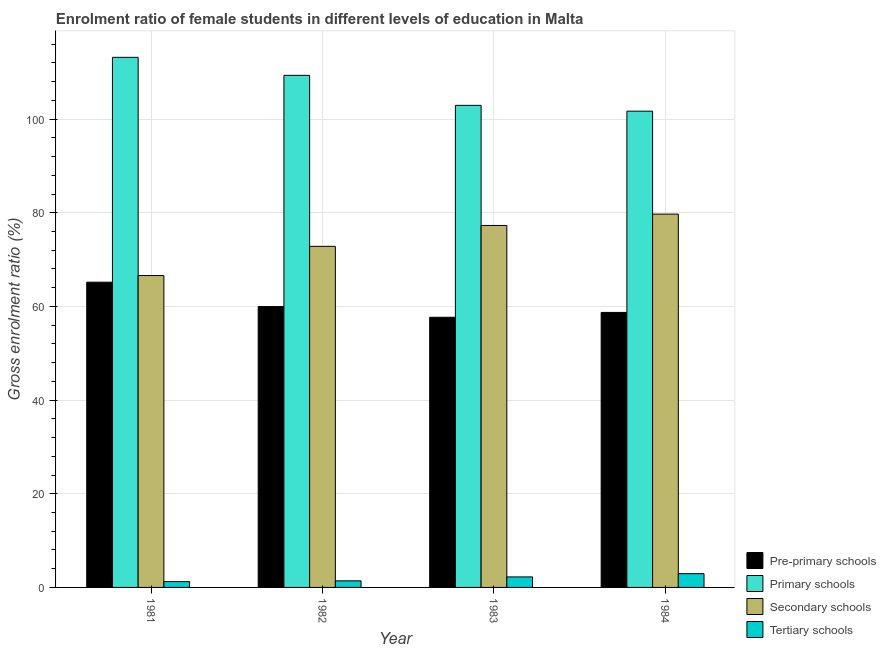How many different coloured bars are there?
Your answer should be very brief. 4. How many groups of bars are there?
Ensure brevity in your answer.  4. How many bars are there on the 1st tick from the left?
Offer a very short reply. 4. What is the label of the 4th group of bars from the left?
Ensure brevity in your answer.  1984. In how many cases, is the number of bars for a given year not equal to the number of legend labels?
Offer a terse response. 0. What is the gross enrolment ratio(male) in secondary schools in 1982?
Provide a short and direct response. 72.84. Across all years, what is the maximum gross enrolment ratio(male) in secondary schools?
Your answer should be compact. 79.72. Across all years, what is the minimum gross enrolment ratio(male) in secondary schools?
Give a very brief answer. 66.6. In which year was the gross enrolment ratio(male) in pre-primary schools minimum?
Ensure brevity in your answer.  1983. What is the total gross enrolment ratio(male) in primary schools in the graph?
Your answer should be compact. 427.19. What is the difference between the gross enrolment ratio(male) in pre-primary schools in 1981 and that in 1982?
Offer a terse response. 5.21. What is the difference between the gross enrolment ratio(male) in primary schools in 1981 and the gross enrolment ratio(male) in secondary schools in 1984?
Your response must be concise. 11.5. What is the average gross enrolment ratio(male) in tertiary schools per year?
Provide a succinct answer. 1.96. What is the ratio of the gross enrolment ratio(male) in pre-primary schools in 1982 to that in 1983?
Offer a terse response. 1.04. Is the difference between the gross enrolment ratio(male) in primary schools in 1983 and 1984 greater than the difference between the gross enrolment ratio(male) in secondary schools in 1983 and 1984?
Give a very brief answer. No. What is the difference between the highest and the second highest gross enrolment ratio(male) in secondary schools?
Give a very brief answer. 2.42. What is the difference between the highest and the lowest gross enrolment ratio(male) in pre-primary schools?
Provide a short and direct response. 7.49. In how many years, is the gross enrolment ratio(male) in tertiary schools greater than the average gross enrolment ratio(male) in tertiary schools taken over all years?
Keep it short and to the point. 2. Is the sum of the gross enrolment ratio(male) in tertiary schools in 1981 and 1984 greater than the maximum gross enrolment ratio(male) in primary schools across all years?
Give a very brief answer. Yes. What does the 4th bar from the left in 1981 represents?
Offer a very short reply. Tertiary schools. What does the 4th bar from the right in 1983 represents?
Give a very brief answer. Pre-primary schools. Is it the case that in every year, the sum of the gross enrolment ratio(male) in pre-primary schools and gross enrolment ratio(male) in primary schools is greater than the gross enrolment ratio(male) in secondary schools?
Offer a terse response. Yes. How many bars are there?
Offer a terse response. 16. What is the difference between two consecutive major ticks on the Y-axis?
Make the answer very short. 20. Does the graph contain grids?
Keep it short and to the point. Yes. How are the legend labels stacked?
Keep it short and to the point. Vertical. What is the title of the graph?
Your response must be concise. Enrolment ratio of female students in different levels of education in Malta. What is the label or title of the X-axis?
Ensure brevity in your answer.  Year. What is the label or title of the Y-axis?
Your response must be concise. Gross enrolment ratio (%). What is the Gross enrolment ratio (%) in Pre-primary schools in 1981?
Offer a terse response. 65.18. What is the Gross enrolment ratio (%) of Primary schools in 1981?
Offer a terse response. 113.2. What is the Gross enrolment ratio (%) of Secondary schools in 1981?
Provide a succinct answer. 66.6. What is the Gross enrolment ratio (%) in Tertiary schools in 1981?
Make the answer very short. 1.24. What is the Gross enrolment ratio (%) of Pre-primary schools in 1982?
Offer a terse response. 59.98. What is the Gross enrolment ratio (%) in Primary schools in 1982?
Provide a succinct answer. 109.35. What is the Gross enrolment ratio (%) in Secondary schools in 1982?
Make the answer very short. 72.84. What is the Gross enrolment ratio (%) of Tertiary schools in 1982?
Keep it short and to the point. 1.4. What is the Gross enrolment ratio (%) in Pre-primary schools in 1983?
Your answer should be compact. 57.69. What is the Gross enrolment ratio (%) in Primary schools in 1983?
Provide a short and direct response. 102.94. What is the Gross enrolment ratio (%) of Secondary schools in 1983?
Offer a very short reply. 77.29. What is the Gross enrolment ratio (%) in Tertiary schools in 1983?
Your answer should be compact. 2.24. What is the Gross enrolment ratio (%) of Pre-primary schools in 1984?
Your answer should be very brief. 58.73. What is the Gross enrolment ratio (%) of Primary schools in 1984?
Ensure brevity in your answer.  101.7. What is the Gross enrolment ratio (%) of Secondary schools in 1984?
Your answer should be compact. 79.72. What is the Gross enrolment ratio (%) in Tertiary schools in 1984?
Offer a very short reply. 2.94. Across all years, what is the maximum Gross enrolment ratio (%) of Pre-primary schools?
Your answer should be compact. 65.18. Across all years, what is the maximum Gross enrolment ratio (%) of Primary schools?
Offer a very short reply. 113.2. Across all years, what is the maximum Gross enrolment ratio (%) of Secondary schools?
Ensure brevity in your answer.  79.72. Across all years, what is the maximum Gross enrolment ratio (%) in Tertiary schools?
Provide a succinct answer. 2.94. Across all years, what is the minimum Gross enrolment ratio (%) in Pre-primary schools?
Offer a very short reply. 57.69. Across all years, what is the minimum Gross enrolment ratio (%) in Primary schools?
Offer a terse response. 101.7. Across all years, what is the minimum Gross enrolment ratio (%) of Secondary schools?
Offer a terse response. 66.6. Across all years, what is the minimum Gross enrolment ratio (%) of Tertiary schools?
Your answer should be compact. 1.24. What is the total Gross enrolment ratio (%) of Pre-primary schools in the graph?
Provide a succinct answer. 241.57. What is the total Gross enrolment ratio (%) of Primary schools in the graph?
Offer a terse response. 427.19. What is the total Gross enrolment ratio (%) of Secondary schools in the graph?
Give a very brief answer. 296.45. What is the total Gross enrolment ratio (%) of Tertiary schools in the graph?
Your answer should be compact. 7.83. What is the difference between the Gross enrolment ratio (%) in Pre-primary schools in 1981 and that in 1982?
Your response must be concise. 5.21. What is the difference between the Gross enrolment ratio (%) of Primary schools in 1981 and that in 1982?
Make the answer very short. 3.85. What is the difference between the Gross enrolment ratio (%) of Secondary schools in 1981 and that in 1982?
Give a very brief answer. -6.24. What is the difference between the Gross enrolment ratio (%) in Tertiary schools in 1981 and that in 1982?
Make the answer very short. -0.16. What is the difference between the Gross enrolment ratio (%) in Pre-primary schools in 1981 and that in 1983?
Ensure brevity in your answer.  7.49. What is the difference between the Gross enrolment ratio (%) in Primary schools in 1981 and that in 1983?
Your answer should be compact. 10.26. What is the difference between the Gross enrolment ratio (%) of Secondary schools in 1981 and that in 1983?
Your answer should be compact. -10.69. What is the difference between the Gross enrolment ratio (%) in Tertiary schools in 1981 and that in 1983?
Provide a succinct answer. -1. What is the difference between the Gross enrolment ratio (%) in Pre-primary schools in 1981 and that in 1984?
Your answer should be compact. 6.46. What is the difference between the Gross enrolment ratio (%) in Primary schools in 1981 and that in 1984?
Provide a short and direct response. 11.5. What is the difference between the Gross enrolment ratio (%) in Secondary schools in 1981 and that in 1984?
Ensure brevity in your answer.  -13.12. What is the difference between the Gross enrolment ratio (%) in Tertiary schools in 1981 and that in 1984?
Your answer should be compact. -1.7. What is the difference between the Gross enrolment ratio (%) of Pre-primary schools in 1982 and that in 1983?
Your response must be concise. 2.29. What is the difference between the Gross enrolment ratio (%) of Primary schools in 1982 and that in 1983?
Your response must be concise. 6.41. What is the difference between the Gross enrolment ratio (%) of Secondary schools in 1982 and that in 1983?
Offer a terse response. -4.46. What is the difference between the Gross enrolment ratio (%) of Tertiary schools in 1982 and that in 1983?
Make the answer very short. -0.84. What is the difference between the Gross enrolment ratio (%) in Pre-primary schools in 1982 and that in 1984?
Offer a terse response. 1.25. What is the difference between the Gross enrolment ratio (%) in Primary schools in 1982 and that in 1984?
Provide a succinct answer. 7.65. What is the difference between the Gross enrolment ratio (%) of Secondary schools in 1982 and that in 1984?
Keep it short and to the point. -6.88. What is the difference between the Gross enrolment ratio (%) of Tertiary schools in 1982 and that in 1984?
Your answer should be compact. -1.54. What is the difference between the Gross enrolment ratio (%) in Pre-primary schools in 1983 and that in 1984?
Give a very brief answer. -1.04. What is the difference between the Gross enrolment ratio (%) in Primary schools in 1983 and that in 1984?
Ensure brevity in your answer.  1.24. What is the difference between the Gross enrolment ratio (%) in Secondary schools in 1983 and that in 1984?
Offer a terse response. -2.42. What is the difference between the Gross enrolment ratio (%) in Tertiary schools in 1983 and that in 1984?
Offer a very short reply. -0.7. What is the difference between the Gross enrolment ratio (%) of Pre-primary schools in 1981 and the Gross enrolment ratio (%) of Primary schools in 1982?
Keep it short and to the point. -44.17. What is the difference between the Gross enrolment ratio (%) in Pre-primary schools in 1981 and the Gross enrolment ratio (%) in Secondary schools in 1982?
Ensure brevity in your answer.  -7.65. What is the difference between the Gross enrolment ratio (%) in Pre-primary schools in 1981 and the Gross enrolment ratio (%) in Tertiary schools in 1982?
Offer a terse response. 63.78. What is the difference between the Gross enrolment ratio (%) of Primary schools in 1981 and the Gross enrolment ratio (%) of Secondary schools in 1982?
Give a very brief answer. 40.36. What is the difference between the Gross enrolment ratio (%) of Primary schools in 1981 and the Gross enrolment ratio (%) of Tertiary schools in 1982?
Give a very brief answer. 111.8. What is the difference between the Gross enrolment ratio (%) of Secondary schools in 1981 and the Gross enrolment ratio (%) of Tertiary schools in 1982?
Keep it short and to the point. 65.2. What is the difference between the Gross enrolment ratio (%) of Pre-primary schools in 1981 and the Gross enrolment ratio (%) of Primary schools in 1983?
Offer a terse response. -37.76. What is the difference between the Gross enrolment ratio (%) in Pre-primary schools in 1981 and the Gross enrolment ratio (%) in Secondary schools in 1983?
Keep it short and to the point. -12.11. What is the difference between the Gross enrolment ratio (%) in Pre-primary schools in 1981 and the Gross enrolment ratio (%) in Tertiary schools in 1983?
Provide a succinct answer. 62.94. What is the difference between the Gross enrolment ratio (%) in Primary schools in 1981 and the Gross enrolment ratio (%) in Secondary schools in 1983?
Make the answer very short. 35.9. What is the difference between the Gross enrolment ratio (%) of Primary schools in 1981 and the Gross enrolment ratio (%) of Tertiary schools in 1983?
Offer a very short reply. 110.95. What is the difference between the Gross enrolment ratio (%) in Secondary schools in 1981 and the Gross enrolment ratio (%) in Tertiary schools in 1983?
Provide a succinct answer. 64.36. What is the difference between the Gross enrolment ratio (%) in Pre-primary schools in 1981 and the Gross enrolment ratio (%) in Primary schools in 1984?
Your answer should be very brief. -36.52. What is the difference between the Gross enrolment ratio (%) of Pre-primary schools in 1981 and the Gross enrolment ratio (%) of Secondary schools in 1984?
Your answer should be very brief. -14.54. What is the difference between the Gross enrolment ratio (%) in Pre-primary schools in 1981 and the Gross enrolment ratio (%) in Tertiary schools in 1984?
Offer a very short reply. 62.24. What is the difference between the Gross enrolment ratio (%) in Primary schools in 1981 and the Gross enrolment ratio (%) in Secondary schools in 1984?
Your answer should be very brief. 33.48. What is the difference between the Gross enrolment ratio (%) in Primary schools in 1981 and the Gross enrolment ratio (%) in Tertiary schools in 1984?
Your answer should be very brief. 110.25. What is the difference between the Gross enrolment ratio (%) in Secondary schools in 1981 and the Gross enrolment ratio (%) in Tertiary schools in 1984?
Give a very brief answer. 63.66. What is the difference between the Gross enrolment ratio (%) of Pre-primary schools in 1982 and the Gross enrolment ratio (%) of Primary schools in 1983?
Offer a very short reply. -42.96. What is the difference between the Gross enrolment ratio (%) in Pre-primary schools in 1982 and the Gross enrolment ratio (%) in Secondary schools in 1983?
Keep it short and to the point. -17.32. What is the difference between the Gross enrolment ratio (%) in Pre-primary schools in 1982 and the Gross enrolment ratio (%) in Tertiary schools in 1983?
Give a very brief answer. 57.73. What is the difference between the Gross enrolment ratio (%) of Primary schools in 1982 and the Gross enrolment ratio (%) of Secondary schools in 1983?
Give a very brief answer. 32.06. What is the difference between the Gross enrolment ratio (%) of Primary schools in 1982 and the Gross enrolment ratio (%) of Tertiary schools in 1983?
Make the answer very short. 107.11. What is the difference between the Gross enrolment ratio (%) of Secondary schools in 1982 and the Gross enrolment ratio (%) of Tertiary schools in 1983?
Offer a terse response. 70.59. What is the difference between the Gross enrolment ratio (%) in Pre-primary schools in 1982 and the Gross enrolment ratio (%) in Primary schools in 1984?
Ensure brevity in your answer.  -41.73. What is the difference between the Gross enrolment ratio (%) in Pre-primary schools in 1982 and the Gross enrolment ratio (%) in Secondary schools in 1984?
Provide a succinct answer. -19.74. What is the difference between the Gross enrolment ratio (%) in Pre-primary schools in 1982 and the Gross enrolment ratio (%) in Tertiary schools in 1984?
Your answer should be very brief. 57.03. What is the difference between the Gross enrolment ratio (%) in Primary schools in 1982 and the Gross enrolment ratio (%) in Secondary schools in 1984?
Provide a succinct answer. 29.63. What is the difference between the Gross enrolment ratio (%) of Primary schools in 1982 and the Gross enrolment ratio (%) of Tertiary schools in 1984?
Offer a terse response. 106.41. What is the difference between the Gross enrolment ratio (%) in Secondary schools in 1982 and the Gross enrolment ratio (%) in Tertiary schools in 1984?
Keep it short and to the point. 69.89. What is the difference between the Gross enrolment ratio (%) of Pre-primary schools in 1983 and the Gross enrolment ratio (%) of Primary schools in 1984?
Offer a terse response. -44.01. What is the difference between the Gross enrolment ratio (%) in Pre-primary schools in 1983 and the Gross enrolment ratio (%) in Secondary schools in 1984?
Keep it short and to the point. -22.03. What is the difference between the Gross enrolment ratio (%) in Pre-primary schools in 1983 and the Gross enrolment ratio (%) in Tertiary schools in 1984?
Make the answer very short. 54.75. What is the difference between the Gross enrolment ratio (%) of Primary schools in 1983 and the Gross enrolment ratio (%) of Secondary schools in 1984?
Your answer should be compact. 23.22. What is the difference between the Gross enrolment ratio (%) in Primary schools in 1983 and the Gross enrolment ratio (%) in Tertiary schools in 1984?
Give a very brief answer. 100. What is the difference between the Gross enrolment ratio (%) in Secondary schools in 1983 and the Gross enrolment ratio (%) in Tertiary schools in 1984?
Your answer should be compact. 74.35. What is the average Gross enrolment ratio (%) of Pre-primary schools per year?
Give a very brief answer. 60.39. What is the average Gross enrolment ratio (%) in Primary schools per year?
Provide a succinct answer. 106.8. What is the average Gross enrolment ratio (%) of Secondary schools per year?
Offer a very short reply. 74.11. What is the average Gross enrolment ratio (%) of Tertiary schools per year?
Keep it short and to the point. 1.96. In the year 1981, what is the difference between the Gross enrolment ratio (%) in Pre-primary schools and Gross enrolment ratio (%) in Primary schools?
Give a very brief answer. -48.02. In the year 1981, what is the difference between the Gross enrolment ratio (%) of Pre-primary schools and Gross enrolment ratio (%) of Secondary schools?
Make the answer very short. -1.42. In the year 1981, what is the difference between the Gross enrolment ratio (%) in Pre-primary schools and Gross enrolment ratio (%) in Tertiary schools?
Provide a short and direct response. 63.94. In the year 1981, what is the difference between the Gross enrolment ratio (%) of Primary schools and Gross enrolment ratio (%) of Secondary schools?
Offer a very short reply. 46.6. In the year 1981, what is the difference between the Gross enrolment ratio (%) of Primary schools and Gross enrolment ratio (%) of Tertiary schools?
Keep it short and to the point. 111.96. In the year 1981, what is the difference between the Gross enrolment ratio (%) of Secondary schools and Gross enrolment ratio (%) of Tertiary schools?
Ensure brevity in your answer.  65.36. In the year 1982, what is the difference between the Gross enrolment ratio (%) in Pre-primary schools and Gross enrolment ratio (%) in Primary schools?
Make the answer very short. -49.38. In the year 1982, what is the difference between the Gross enrolment ratio (%) in Pre-primary schools and Gross enrolment ratio (%) in Secondary schools?
Offer a very short reply. -12.86. In the year 1982, what is the difference between the Gross enrolment ratio (%) of Pre-primary schools and Gross enrolment ratio (%) of Tertiary schools?
Make the answer very short. 58.57. In the year 1982, what is the difference between the Gross enrolment ratio (%) of Primary schools and Gross enrolment ratio (%) of Secondary schools?
Offer a very short reply. 36.52. In the year 1982, what is the difference between the Gross enrolment ratio (%) of Primary schools and Gross enrolment ratio (%) of Tertiary schools?
Give a very brief answer. 107.95. In the year 1982, what is the difference between the Gross enrolment ratio (%) in Secondary schools and Gross enrolment ratio (%) in Tertiary schools?
Your answer should be compact. 71.43. In the year 1983, what is the difference between the Gross enrolment ratio (%) of Pre-primary schools and Gross enrolment ratio (%) of Primary schools?
Provide a succinct answer. -45.25. In the year 1983, what is the difference between the Gross enrolment ratio (%) of Pre-primary schools and Gross enrolment ratio (%) of Secondary schools?
Ensure brevity in your answer.  -19.6. In the year 1983, what is the difference between the Gross enrolment ratio (%) in Pre-primary schools and Gross enrolment ratio (%) in Tertiary schools?
Your answer should be compact. 55.45. In the year 1983, what is the difference between the Gross enrolment ratio (%) in Primary schools and Gross enrolment ratio (%) in Secondary schools?
Your answer should be compact. 25.65. In the year 1983, what is the difference between the Gross enrolment ratio (%) in Primary schools and Gross enrolment ratio (%) in Tertiary schools?
Provide a short and direct response. 100.7. In the year 1983, what is the difference between the Gross enrolment ratio (%) in Secondary schools and Gross enrolment ratio (%) in Tertiary schools?
Offer a very short reply. 75.05. In the year 1984, what is the difference between the Gross enrolment ratio (%) of Pre-primary schools and Gross enrolment ratio (%) of Primary schools?
Ensure brevity in your answer.  -42.98. In the year 1984, what is the difference between the Gross enrolment ratio (%) in Pre-primary schools and Gross enrolment ratio (%) in Secondary schools?
Keep it short and to the point. -20.99. In the year 1984, what is the difference between the Gross enrolment ratio (%) in Pre-primary schools and Gross enrolment ratio (%) in Tertiary schools?
Keep it short and to the point. 55.78. In the year 1984, what is the difference between the Gross enrolment ratio (%) in Primary schools and Gross enrolment ratio (%) in Secondary schools?
Keep it short and to the point. 21.99. In the year 1984, what is the difference between the Gross enrolment ratio (%) of Primary schools and Gross enrolment ratio (%) of Tertiary schools?
Provide a succinct answer. 98.76. In the year 1984, what is the difference between the Gross enrolment ratio (%) of Secondary schools and Gross enrolment ratio (%) of Tertiary schools?
Your answer should be very brief. 76.77. What is the ratio of the Gross enrolment ratio (%) in Pre-primary schools in 1981 to that in 1982?
Ensure brevity in your answer.  1.09. What is the ratio of the Gross enrolment ratio (%) of Primary schools in 1981 to that in 1982?
Offer a very short reply. 1.04. What is the ratio of the Gross enrolment ratio (%) in Secondary schools in 1981 to that in 1982?
Your response must be concise. 0.91. What is the ratio of the Gross enrolment ratio (%) in Tertiary schools in 1981 to that in 1982?
Offer a very short reply. 0.88. What is the ratio of the Gross enrolment ratio (%) in Pre-primary schools in 1981 to that in 1983?
Provide a short and direct response. 1.13. What is the ratio of the Gross enrolment ratio (%) of Primary schools in 1981 to that in 1983?
Keep it short and to the point. 1.1. What is the ratio of the Gross enrolment ratio (%) of Secondary schools in 1981 to that in 1983?
Your response must be concise. 0.86. What is the ratio of the Gross enrolment ratio (%) in Tertiary schools in 1981 to that in 1983?
Provide a short and direct response. 0.55. What is the ratio of the Gross enrolment ratio (%) of Pre-primary schools in 1981 to that in 1984?
Make the answer very short. 1.11. What is the ratio of the Gross enrolment ratio (%) in Primary schools in 1981 to that in 1984?
Offer a very short reply. 1.11. What is the ratio of the Gross enrolment ratio (%) of Secondary schools in 1981 to that in 1984?
Make the answer very short. 0.84. What is the ratio of the Gross enrolment ratio (%) of Tertiary schools in 1981 to that in 1984?
Ensure brevity in your answer.  0.42. What is the ratio of the Gross enrolment ratio (%) of Pre-primary schools in 1982 to that in 1983?
Keep it short and to the point. 1.04. What is the ratio of the Gross enrolment ratio (%) of Primary schools in 1982 to that in 1983?
Keep it short and to the point. 1.06. What is the ratio of the Gross enrolment ratio (%) in Secondary schools in 1982 to that in 1983?
Provide a short and direct response. 0.94. What is the ratio of the Gross enrolment ratio (%) in Tertiary schools in 1982 to that in 1983?
Your response must be concise. 0.63. What is the ratio of the Gross enrolment ratio (%) in Pre-primary schools in 1982 to that in 1984?
Provide a short and direct response. 1.02. What is the ratio of the Gross enrolment ratio (%) of Primary schools in 1982 to that in 1984?
Give a very brief answer. 1.08. What is the ratio of the Gross enrolment ratio (%) in Secondary schools in 1982 to that in 1984?
Make the answer very short. 0.91. What is the ratio of the Gross enrolment ratio (%) of Tertiary schools in 1982 to that in 1984?
Make the answer very short. 0.48. What is the ratio of the Gross enrolment ratio (%) of Pre-primary schools in 1983 to that in 1984?
Your answer should be very brief. 0.98. What is the ratio of the Gross enrolment ratio (%) of Primary schools in 1983 to that in 1984?
Give a very brief answer. 1.01. What is the ratio of the Gross enrolment ratio (%) in Secondary schools in 1983 to that in 1984?
Give a very brief answer. 0.97. What is the ratio of the Gross enrolment ratio (%) of Tertiary schools in 1983 to that in 1984?
Make the answer very short. 0.76. What is the difference between the highest and the second highest Gross enrolment ratio (%) in Pre-primary schools?
Give a very brief answer. 5.21. What is the difference between the highest and the second highest Gross enrolment ratio (%) of Primary schools?
Provide a succinct answer. 3.85. What is the difference between the highest and the second highest Gross enrolment ratio (%) in Secondary schools?
Give a very brief answer. 2.42. What is the difference between the highest and the second highest Gross enrolment ratio (%) in Tertiary schools?
Your answer should be very brief. 0.7. What is the difference between the highest and the lowest Gross enrolment ratio (%) in Pre-primary schools?
Your answer should be very brief. 7.49. What is the difference between the highest and the lowest Gross enrolment ratio (%) in Primary schools?
Your answer should be compact. 11.5. What is the difference between the highest and the lowest Gross enrolment ratio (%) of Secondary schools?
Your answer should be compact. 13.12. What is the difference between the highest and the lowest Gross enrolment ratio (%) of Tertiary schools?
Offer a terse response. 1.7. 